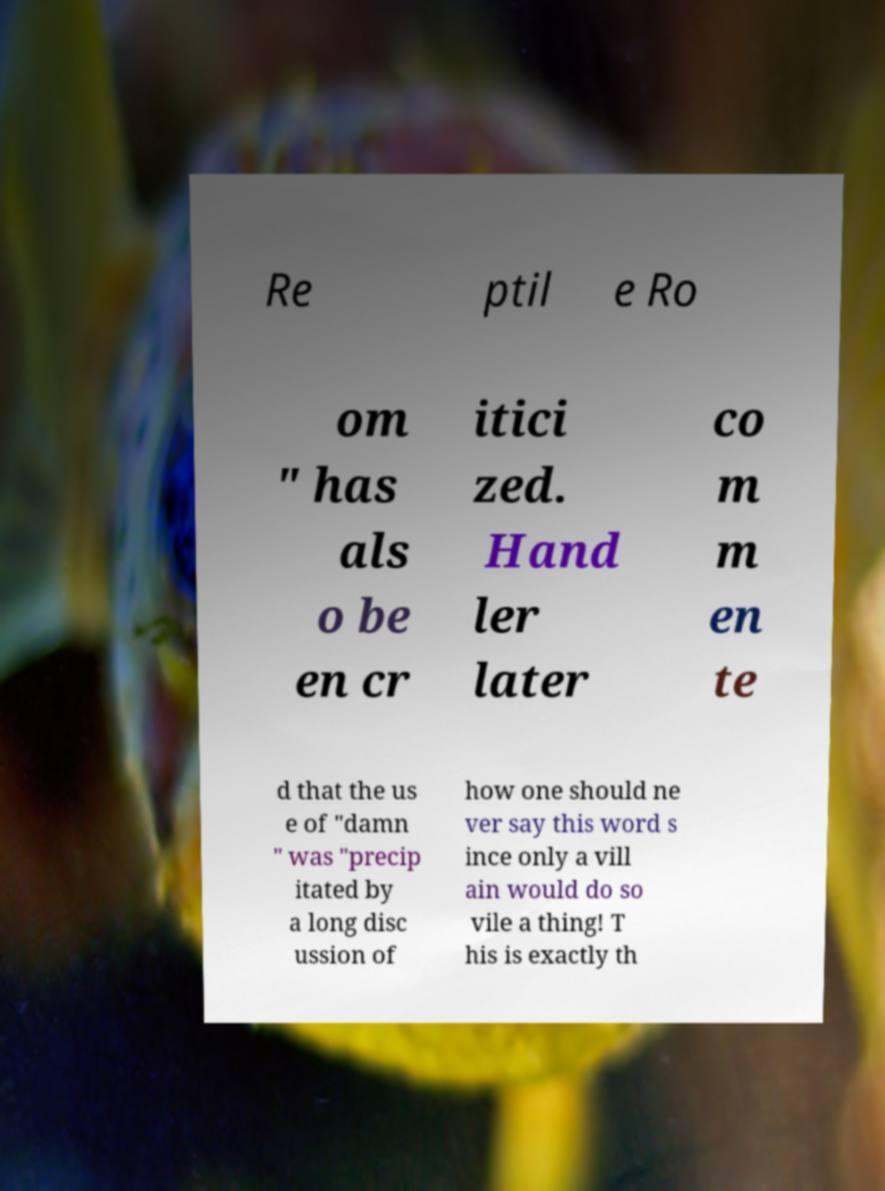I need the written content from this picture converted into text. Can you do that? Re ptil e Ro om " has als o be en cr itici zed. Hand ler later co m m en te d that the us e of "damn " was "precip itated by a long disc ussion of how one should ne ver say this word s ince only a vill ain would do so vile a thing! T his is exactly th 